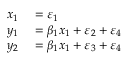Convert formula to latex. <formula><loc_0><loc_0><loc_500><loc_500>\begin{array} { r l } { x _ { 1 } } & = \varepsilon _ { 1 } } \\ { y _ { 1 } } & = \beta _ { 1 } x _ { 1 } + \varepsilon _ { 2 } + \varepsilon _ { 4 } } \\ { y _ { 2 } } & = \beta _ { 1 } x _ { 1 } + \varepsilon _ { 3 } + \varepsilon _ { 4 } } \end{array}</formula> 